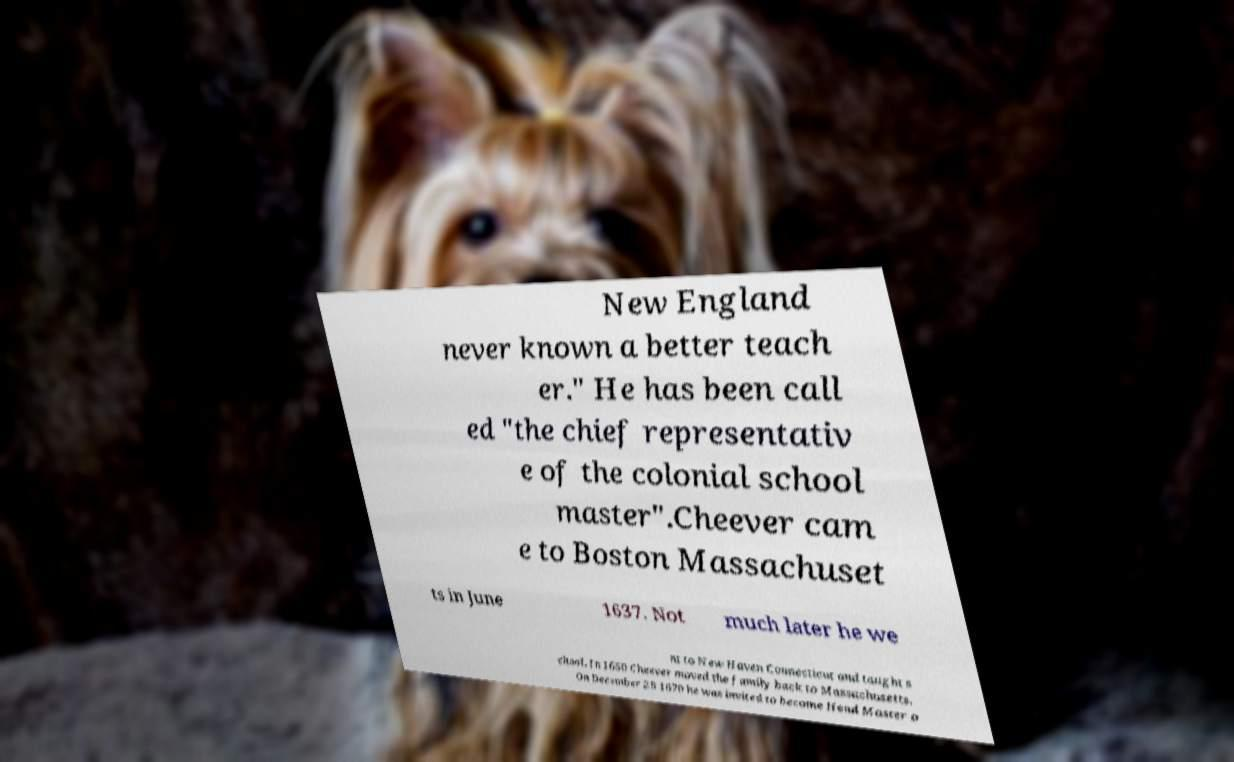Can you accurately transcribe the text from the provided image for me? New England never known a better teach er." He has been call ed "the chief representativ e of the colonial school master".Cheever cam e to Boston Massachuset ts in June 1637. Not much later he we nt to New Haven Connecticut and taught s chool. In 1650 Cheever moved the family back to Massachusetts. On December 29 1670 he was invited to become Head Master o 